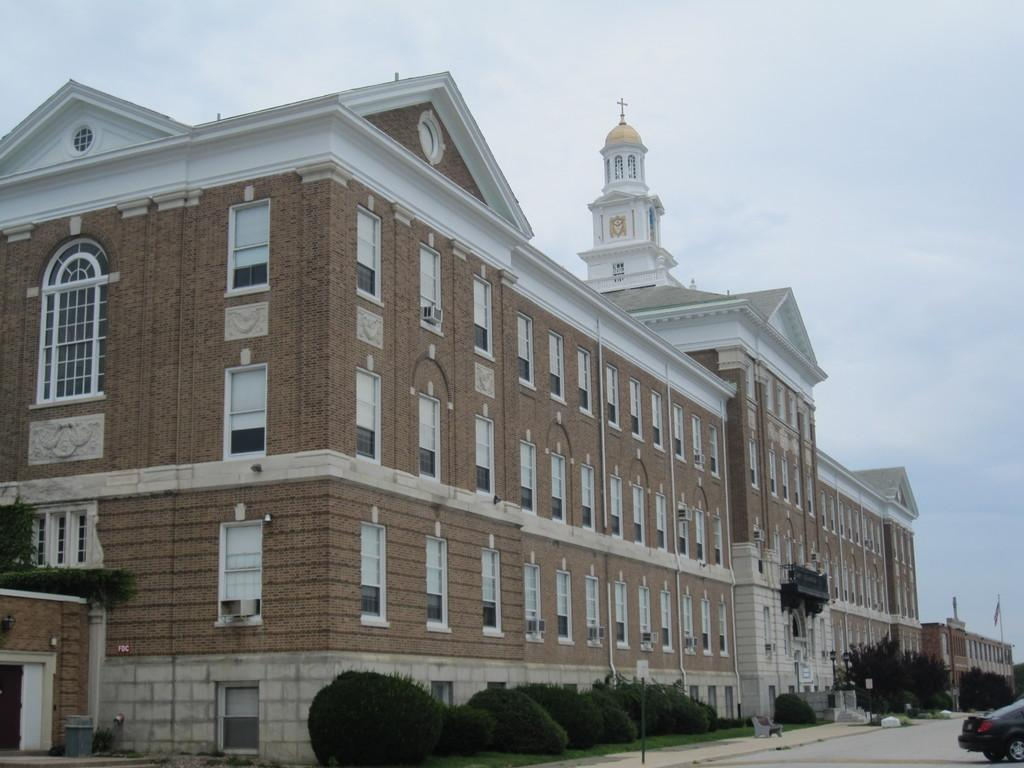What is the main structure in the center of the image? There is a building in the center of the image. What type of vegetation can be seen in the image? There are plants in the image. What is the purpose of the road in the image? The road in the image is likely for transportation. What vehicle is present in the image? There is a car in the image. What is visible at the top of the image? The sky is visible at the top of the image. What type of flame can be seen coming from the building in the image? There is no flame present in the image; it features a building, plants, a road, a car, and the sky. 